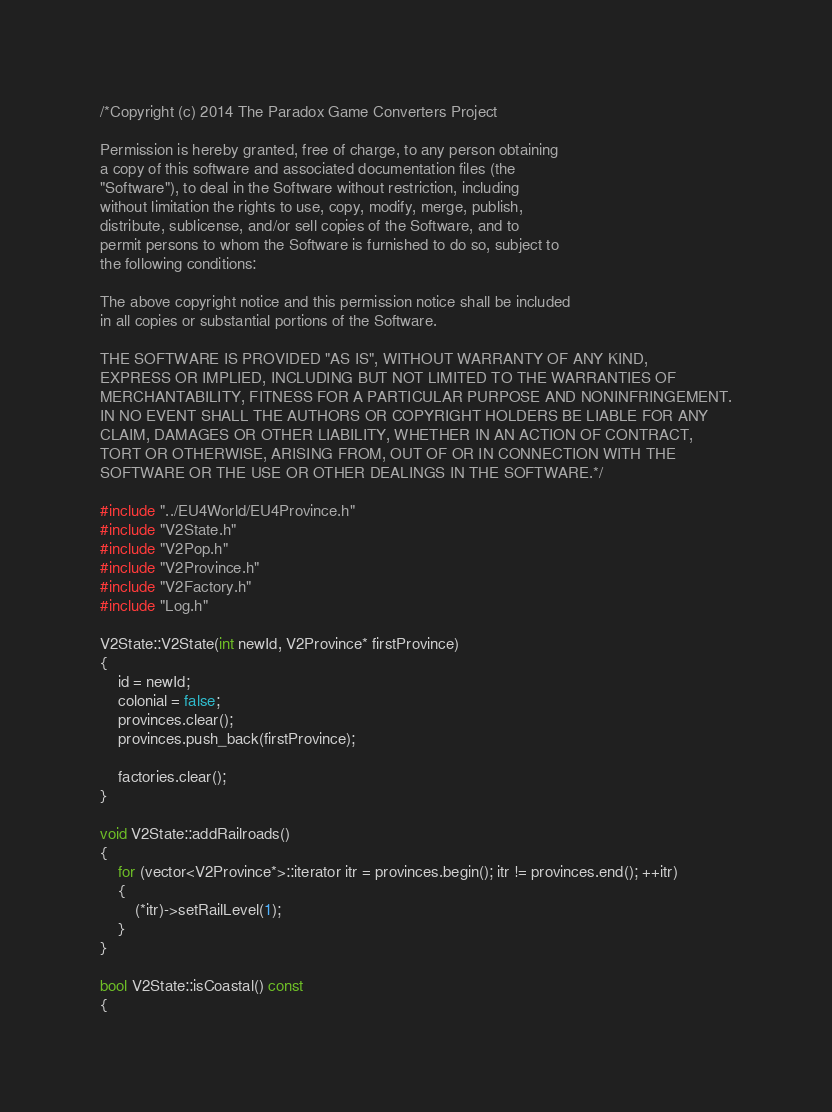<code> <loc_0><loc_0><loc_500><loc_500><_C++_>/*Copyright (c) 2014 The Paradox Game Converters Project

Permission is hereby granted, free of charge, to any person obtaining
a copy of this software and associated documentation files (the
"Software"), to deal in the Software without restriction, including
without limitation the rights to use, copy, modify, merge, publish,
distribute, sublicense, and/or sell copies of the Software, and to
permit persons to whom the Software is furnished to do so, subject to
the following conditions:

The above copyright notice and this permission notice shall be included
in all copies or substantial portions of the Software.

THE SOFTWARE IS PROVIDED "AS IS", WITHOUT WARRANTY OF ANY KIND,
EXPRESS OR IMPLIED, INCLUDING BUT NOT LIMITED TO THE WARRANTIES OF
MERCHANTABILITY, FITNESS FOR A PARTICULAR PURPOSE AND NONINFRINGEMENT.
IN NO EVENT SHALL THE AUTHORS OR COPYRIGHT HOLDERS BE LIABLE FOR ANY
CLAIM, DAMAGES OR OTHER LIABILITY, WHETHER IN AN ACTION OF CONTRACT,
TORT OR OTHERWISE, ARISING FROM, OUT OF OR IN CONNECTION WITH THE
SOFTWARE OR THE USE OR OTHER DEALINGS IN THE SOFTWARE.*/

#include "../EU4World/EU4Province.h"
#include "V2State.h"
#include "V2Pop.h"
#include "V2Province.h"
#include "V2Factory.h"
#include "Log.h"

V2State::V2State(int newId, V2Province* firstProvince)
{
	id = newId;
	colonial = false;
	provinces.clear();
	provinces.push_back(firstProvince);

	factories.clear();
}

void V2State::addRailroads()
{
	for (vector<V2Province*>::iterator itr = provinces.begin(); itr != provinces.end(); ++itr)
	{
		(*itr)->setRailLevel(1);
	}
}

bool V2State::isCoastal() const
{</code> 